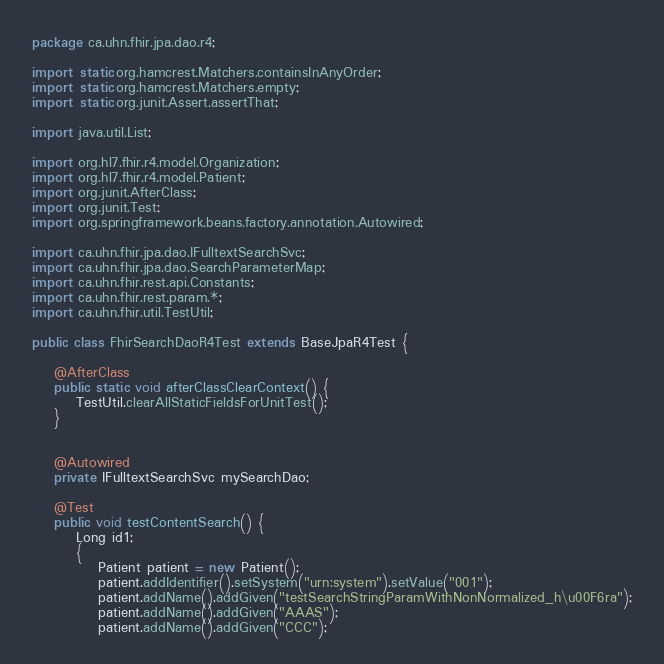<code> <loc_0><loc_0><loc_500><loc_500><_Java_>package ca.uhn.fhir.jpa.dao.r4;

import static org.hamcrest.Matchers.containsInAnyOrder;
import static org.hamcrest.Matchers.empty;
import static org.junit.Assert.assertThat;

import java.util.List;

import org.hl7.fhir.r4.model.Organization;
import org.hl7.fhir.r4.model.Patient;
import org.junit.AfterClass;
import org.junit.Test;
import org.springframework.beans.factory.annotation.Autowired;

import ca.uhn.fhir.jpa.dao.IFulltextSearchSvc;
import ca.uhn.fhir.jpa.dao.SearchParameterMap;
import ca.uhn.fhir.rest.api.Constants;
import ca.uhn.fhir.rest.param.*;
import ca.uhn.fhir.util.TestUtil;

public class FhirSearchDaoR4Test extends BaseJpaR4Test {

	@AfterClass
	public static void afterClassClearContext() {
		TestUtil.clearAllStaticFieldsForUnitTest();
	}


	@Autowired
	private IFulltextSearchSvc mySearchDao;
	
	@Test
	public void testContentSearch() {
		Long id1;
		{
			Patient patient = new Patient();
			patient.addIdentifier().setSystem("urn:system").setValue("001");
			patient.addName().addGiven("testSearchStringParamWithNonNormalized_h\u00F6ra");
			patient.addName().addGiven("AAAS");
			patient.addName().addGiven("CCC");</code> 